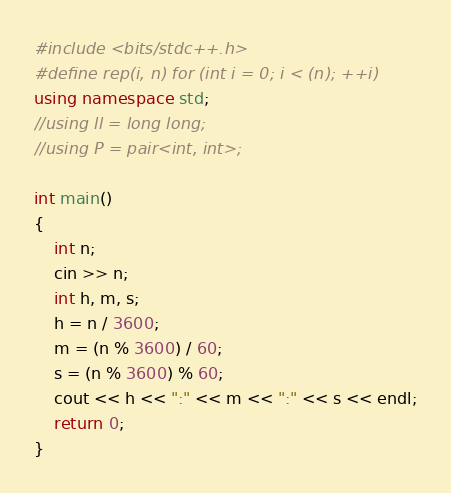<code> <loc_0><loc_0><loc_500><loc_500><_C++_>#include <bits/stdc++.h>
#define rep(i, n) for (int i = 0; i < (n); ++i)
using namespace std;
//using ll = long long;
//using P = pair<int, int>;

int main()
{
    int n;
    cin >> n;
    int h, m, s;
    h = n / 3600;
    m = (n % 3600) / 60;
    s = (n % 3600) % 60;
    cout << h << ":" << m << ":" << s << endl;
    return 0;
}
</code> 